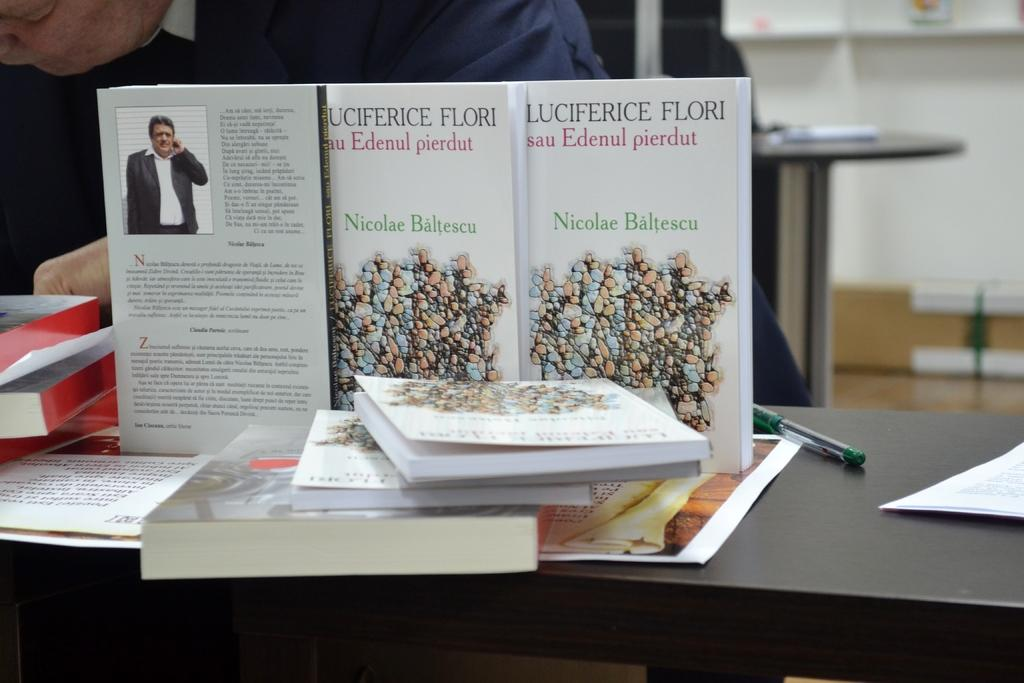<image>
Provide a brief description of the given image. Several books on a display with the author named as Nicolae Baltescu. 